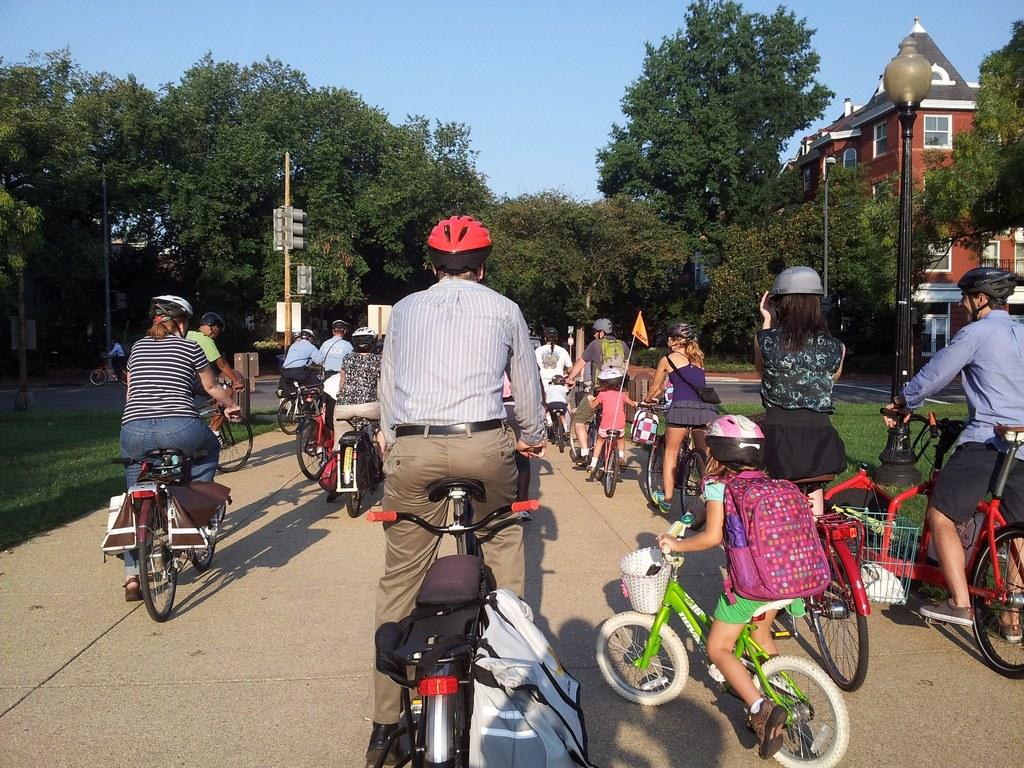What are the people in the image doing? The people in the image are riding bicycles on a road. What can be seen near the road in the image? There are trees near the road in the image. What type of structures are on the right side of the road? There are houses on the right side of the road. What is visible at the top of the image? The sky is visible at the top of the image. Can you see any guitars being played by the people riding bicycles in the image? There are no guitars visible in the image; the people are riding bicycles. How many cows can be seen grazing near the houses on the right side of the road? There are no cows present in the image; the image only shows people riding bicycles, trees, houses, and the sky. 